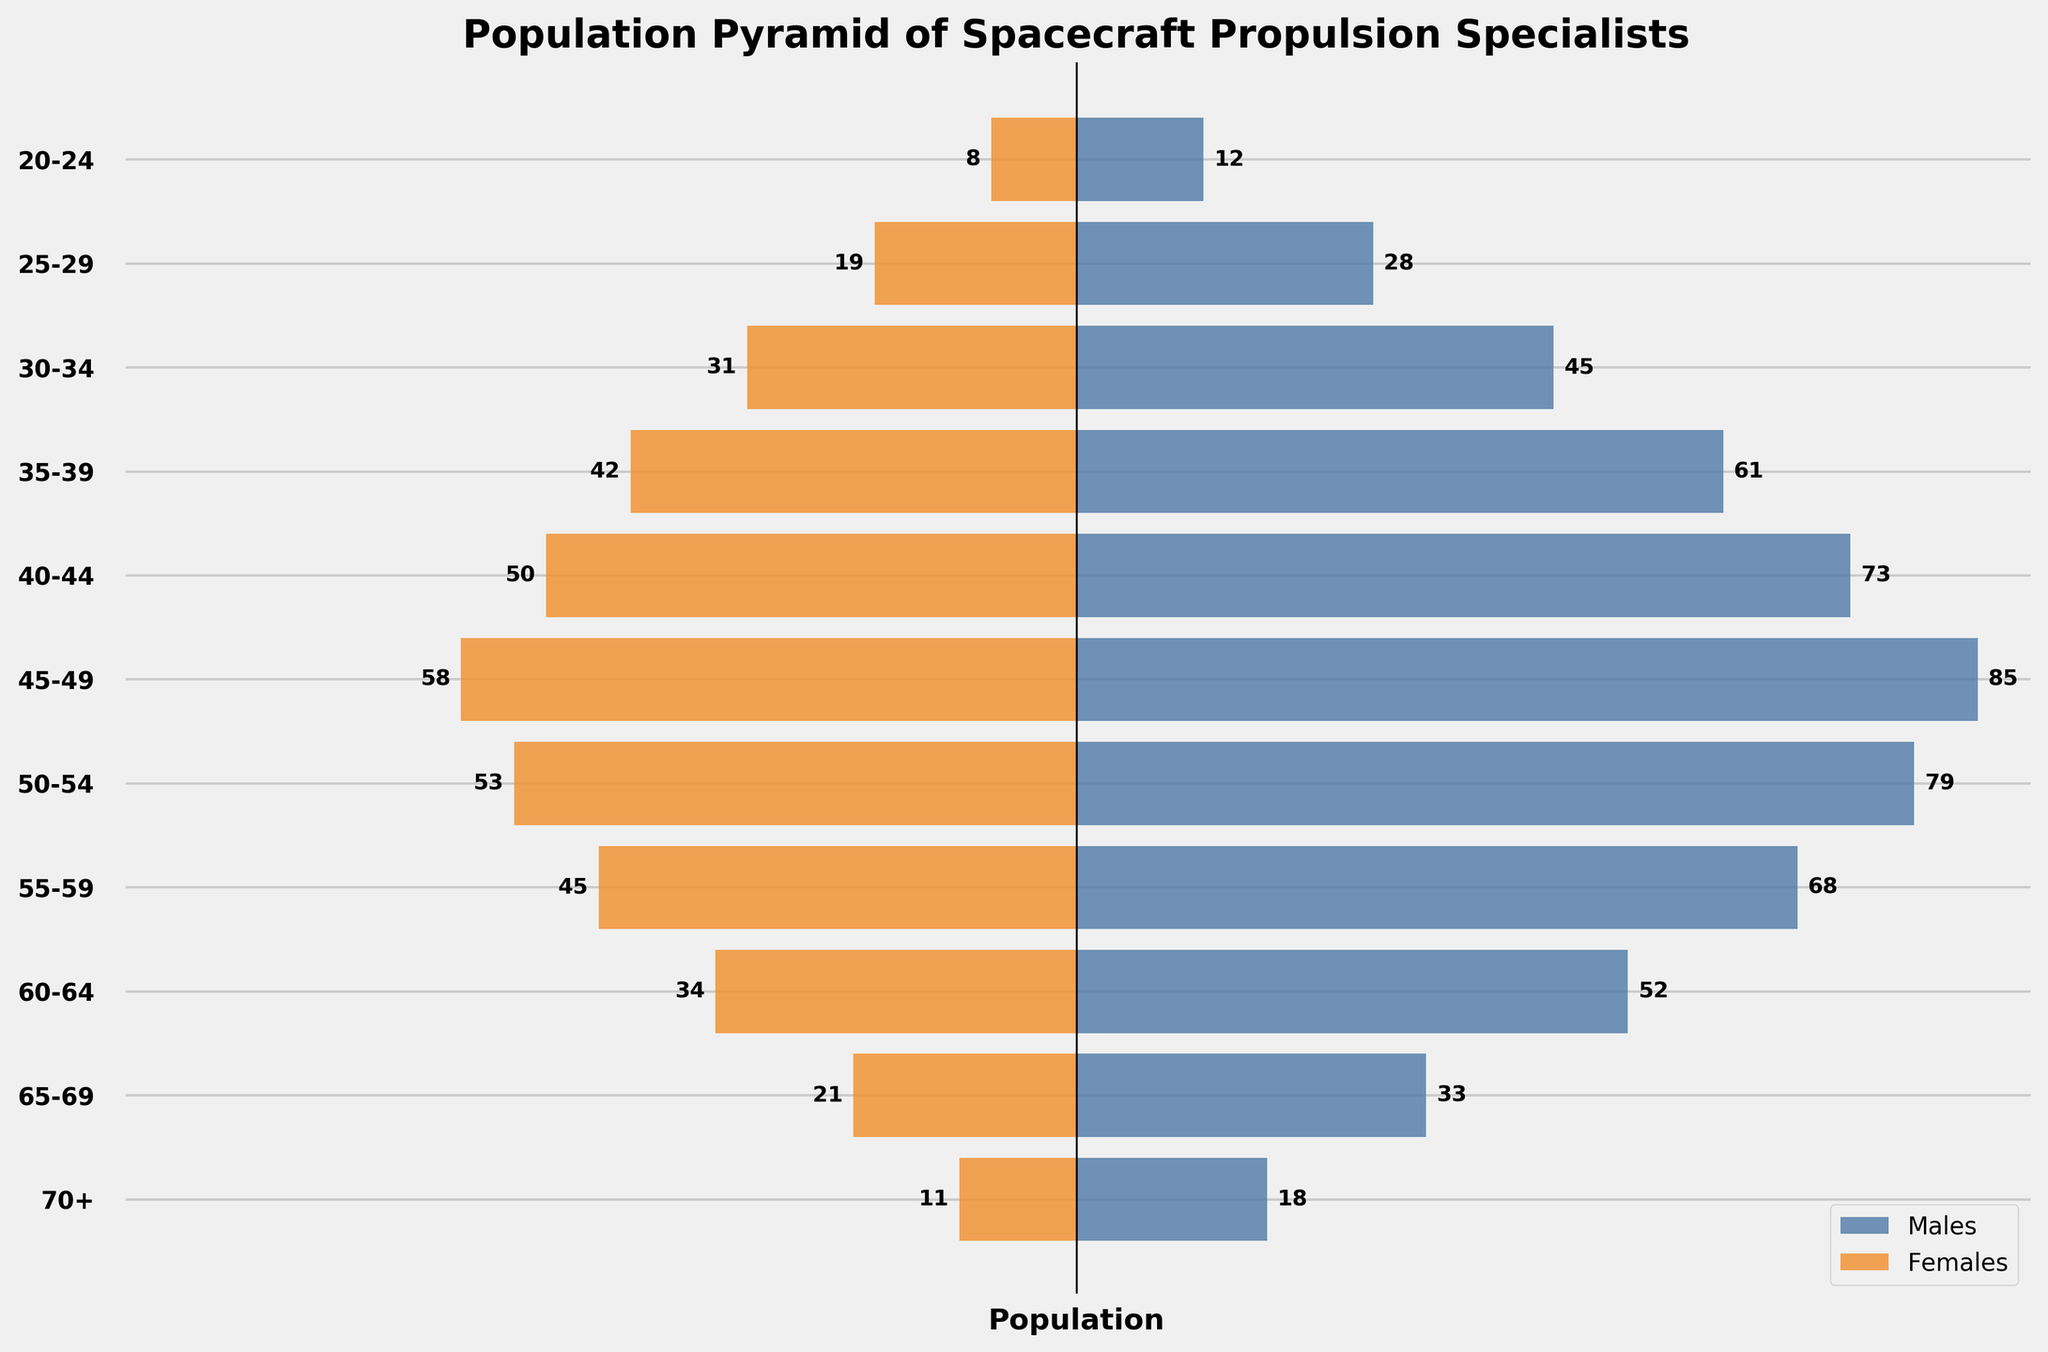What's the title of the figure? The title is written at the top of the figure, showing what the visual data represents.
Answer: Population Pyramid of Spacecraft Propulsion Specialists What age group has the highest number of male specialists? The bar for males in the 45-49 age group has the longest positive length, indicating the highest number.
Answer: 45-49 What is the total number of female specialists aged 25-34? To find the total, add the female specialists in 25-29 and 30-34 age groups. 19 + 31 = 50.
Answer: 50 Which gender has more specialists in the 35-39 age group? Compare the lengths of the bars for both genders in the 35-39 age group. The male bar is longer than the female bar.
Answer: Males What age group has the smallest number of female specialists, and what is that number? The shortest bar on the negative side represents females in the 70+ age group, which has the smallest number of female specialists.
Answer: 70+, 11 How does the proportion of male specialists change from the 20-24 age group to the 45-49 age group? Compare the lengths of the bars for males between these two age groups. The number increases from 12 to 85.
Answer: It increases What is the difference in the number of specialists between males and females in the 50-54 age group? Subtract the number of females from the number of males: 79 - 53 = 26.
Answer: 26 Which age group has the greatest disparity between genders and what is that disparity? Look for the age group with the largest absolute difference between male and female specialists. For 45-49: 85 - 58 = 27, the largest difference.
Answer: 45-49, 27 Which gender has more specialists in the 60-64 age group? Compare the lengths of the bars for both genders in the 60-64 age group. The male bar is longer than the female bar.
Answer: Males Is the total number of specialists aged 40-49 greater than those aged 60+ for both genders? Total for 40-49: 73+85+50+58 = 266, Total for 60+: 52+33+18+34+21+11 = 169. 266 is greater than 169.
Answer: Yes What trend can be observed in the number of specialists as the age increases for both genders? Observe the pattern of the bar lengths as age increases. Numbers peak around 45-49 for both genders and then decline progressively.
Answer: Increase until 45-49, then decline 